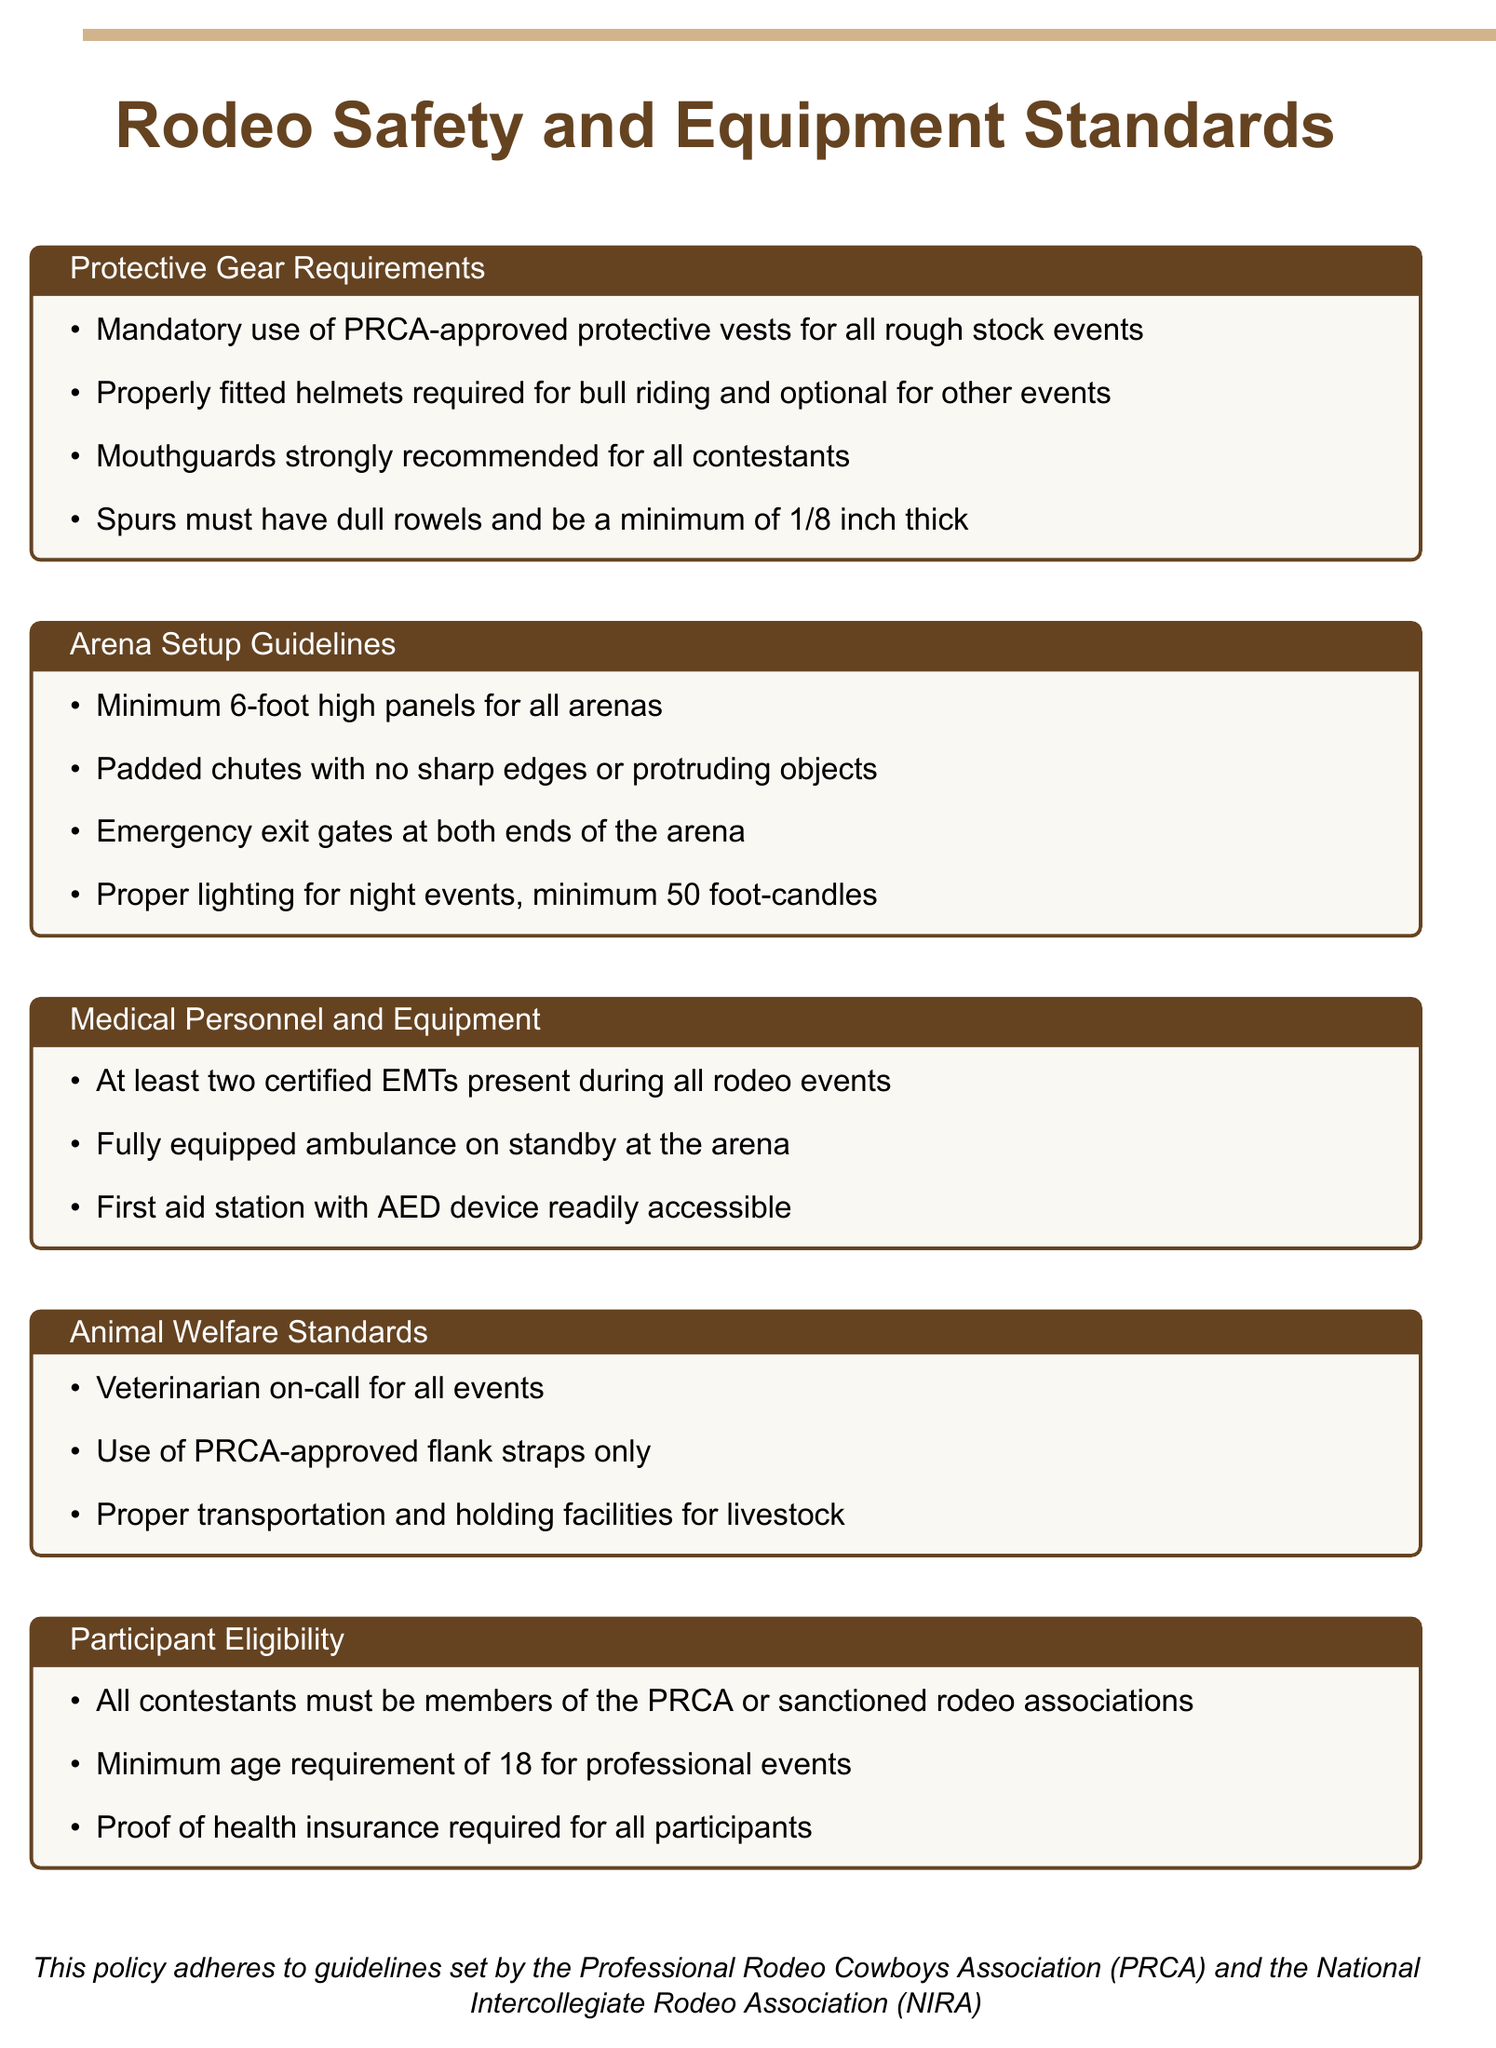What is the required height for arena panels? The minimum height for arena panels is specified in the guidelines section of the document.
Answer: 6-foot What is mandatory for all rough stock events? The document states a requirement for protective gear specific to rough stock events.
Answer: PRCA-approved protective vests How many EMTs must be present during rodeo events? The medical personnel section of the document specifies the number of EMTs required.
Answer: At least two What type of lighting is necessary for night events? The arena setup guidelines detail the lighting requirements for nighttime events.
Answer: Minimum 50 foot-candles What is the minimum age for professional rodeo events? The participant eligibility section provides the age requirement for contestants.
Answer: 18 Which organization must all contestants be members of? The eligibility requirements indicate the association relevant to contestants.
Answer: PRCA or sanctioned rodeo associations What equipment must be readily accessible at the first aid station? The medical personnel section lists the necessary equipment for first aid stations.
Answer: AED device What must be done for the transportation of livestock? The animal welfare standards describe the necessary conditions for livestock transportation.
Answer: Proper transportation and holding facilities 